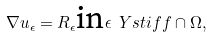Convert formula to latex. <formula><loc_0><loc_0><loc_500><loc_500>\nabla u _ { \epsilon } = R _ { \epsilon } \text {in} \epsilon \ Y s t i f f \cap \Omega ,</formula> 